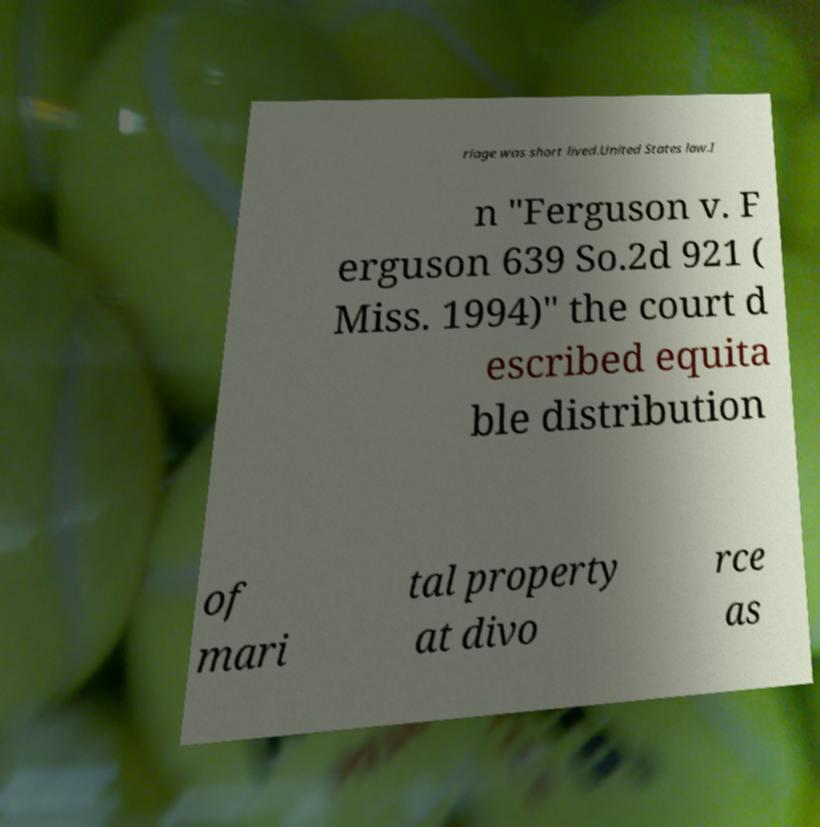Can you read and provide the text displayed in the image?This photo seems to have some interesting text. Can you extract and type it out for me? riage was short lived.United States law.I n "Ferguson v. F erguson 639 So.2d 921 ( Miss. 1994)" the court d escribed equita ble distribution of mari tal property at divo rce as 